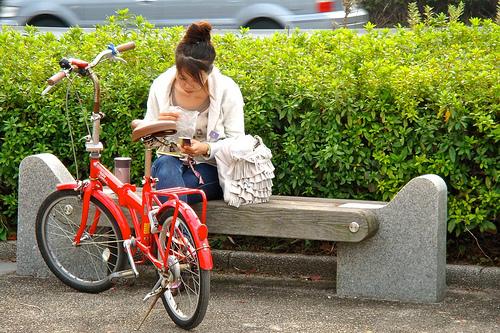Are there ruffles on her purse?
Keep it brief. Yes. Is there a green hedge?
Concise answer only. Yes. What color is the bike?
Short answer required. Red. Where is the bench?
Be succinct. Park. What is the lady doing?
Short answer required. Sitting. What is next to the woman?
Answer briefly. Bicycle. 